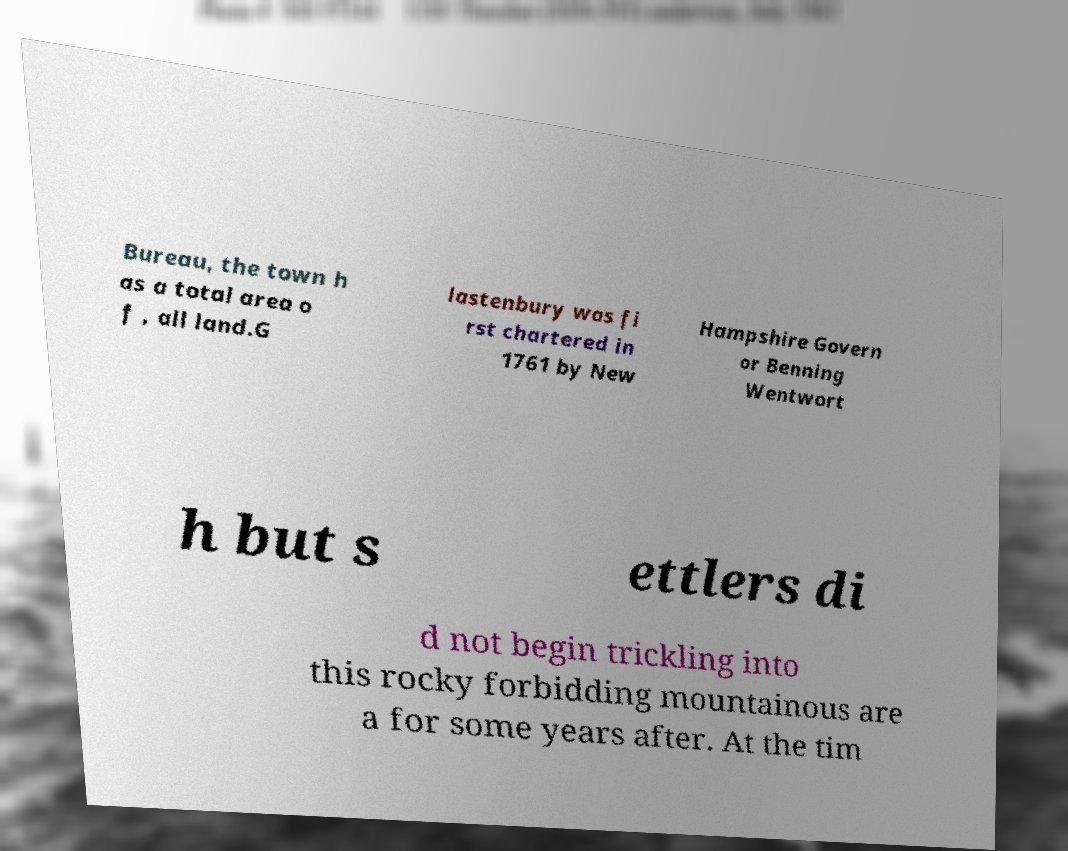There's text embedded in this image that I need extracted. Can you transcribe it verbatim? Bureau, the town h as a total area o f , all land.G lastenbury was fi rst chartered in 1761 by New Hampshire Govern or Benning Wentwort h but s ettlers di d not begin trickling into this rocky forbidding mountainous are a for some years after. At the tim 